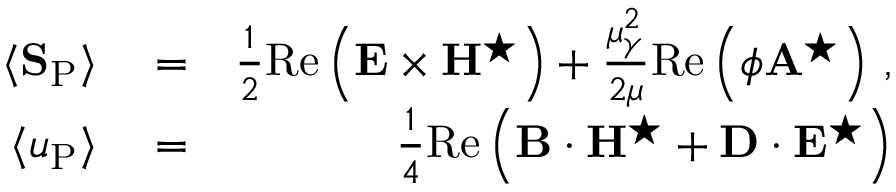Convert formula to latex. <formula><loc_0><loc_0><loc_500><loc_500>\begin{array} { r l r } { \langle { S } _ { P } \rangle } & = } & { \frac { 1 } { 2 } R e \left ( { E } \times { H } ^ { ^ { * } } \right ) + \frac { \mu _ { \gamma } ^ { 2 } } { 2 \mu } R e \left ( \phi { A } ^ { ^ { * } } \right ) \, , } \\ { \langle u _ { P } \rangle } & = } & { \frac { 1 } { 4 } R e \left ( { B } \cdot { H } ^ { ^ { * } } + { D } \cdot { E } ^ { ^ { * } } \right ) } \end{array}</formula> 